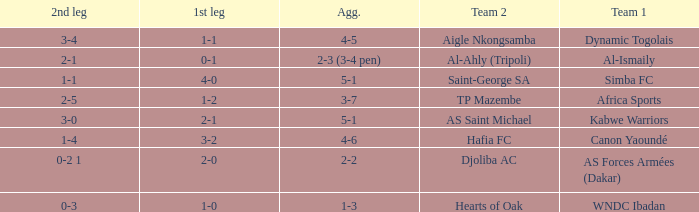When Kabwe Warriors (team 1) played, what was the result of the 1st leg? 2-1. 